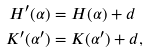<formula> <loc_0><loc_0><loc_500><loc_500>H ^ { \prime } ( \alpha ) & = H ( \alpha ) + d \\ K ^ { \prime } ( \alpha ^ { \prime } ) & = K ( \alpha ^ { \prime } ) + d ,</formula> 